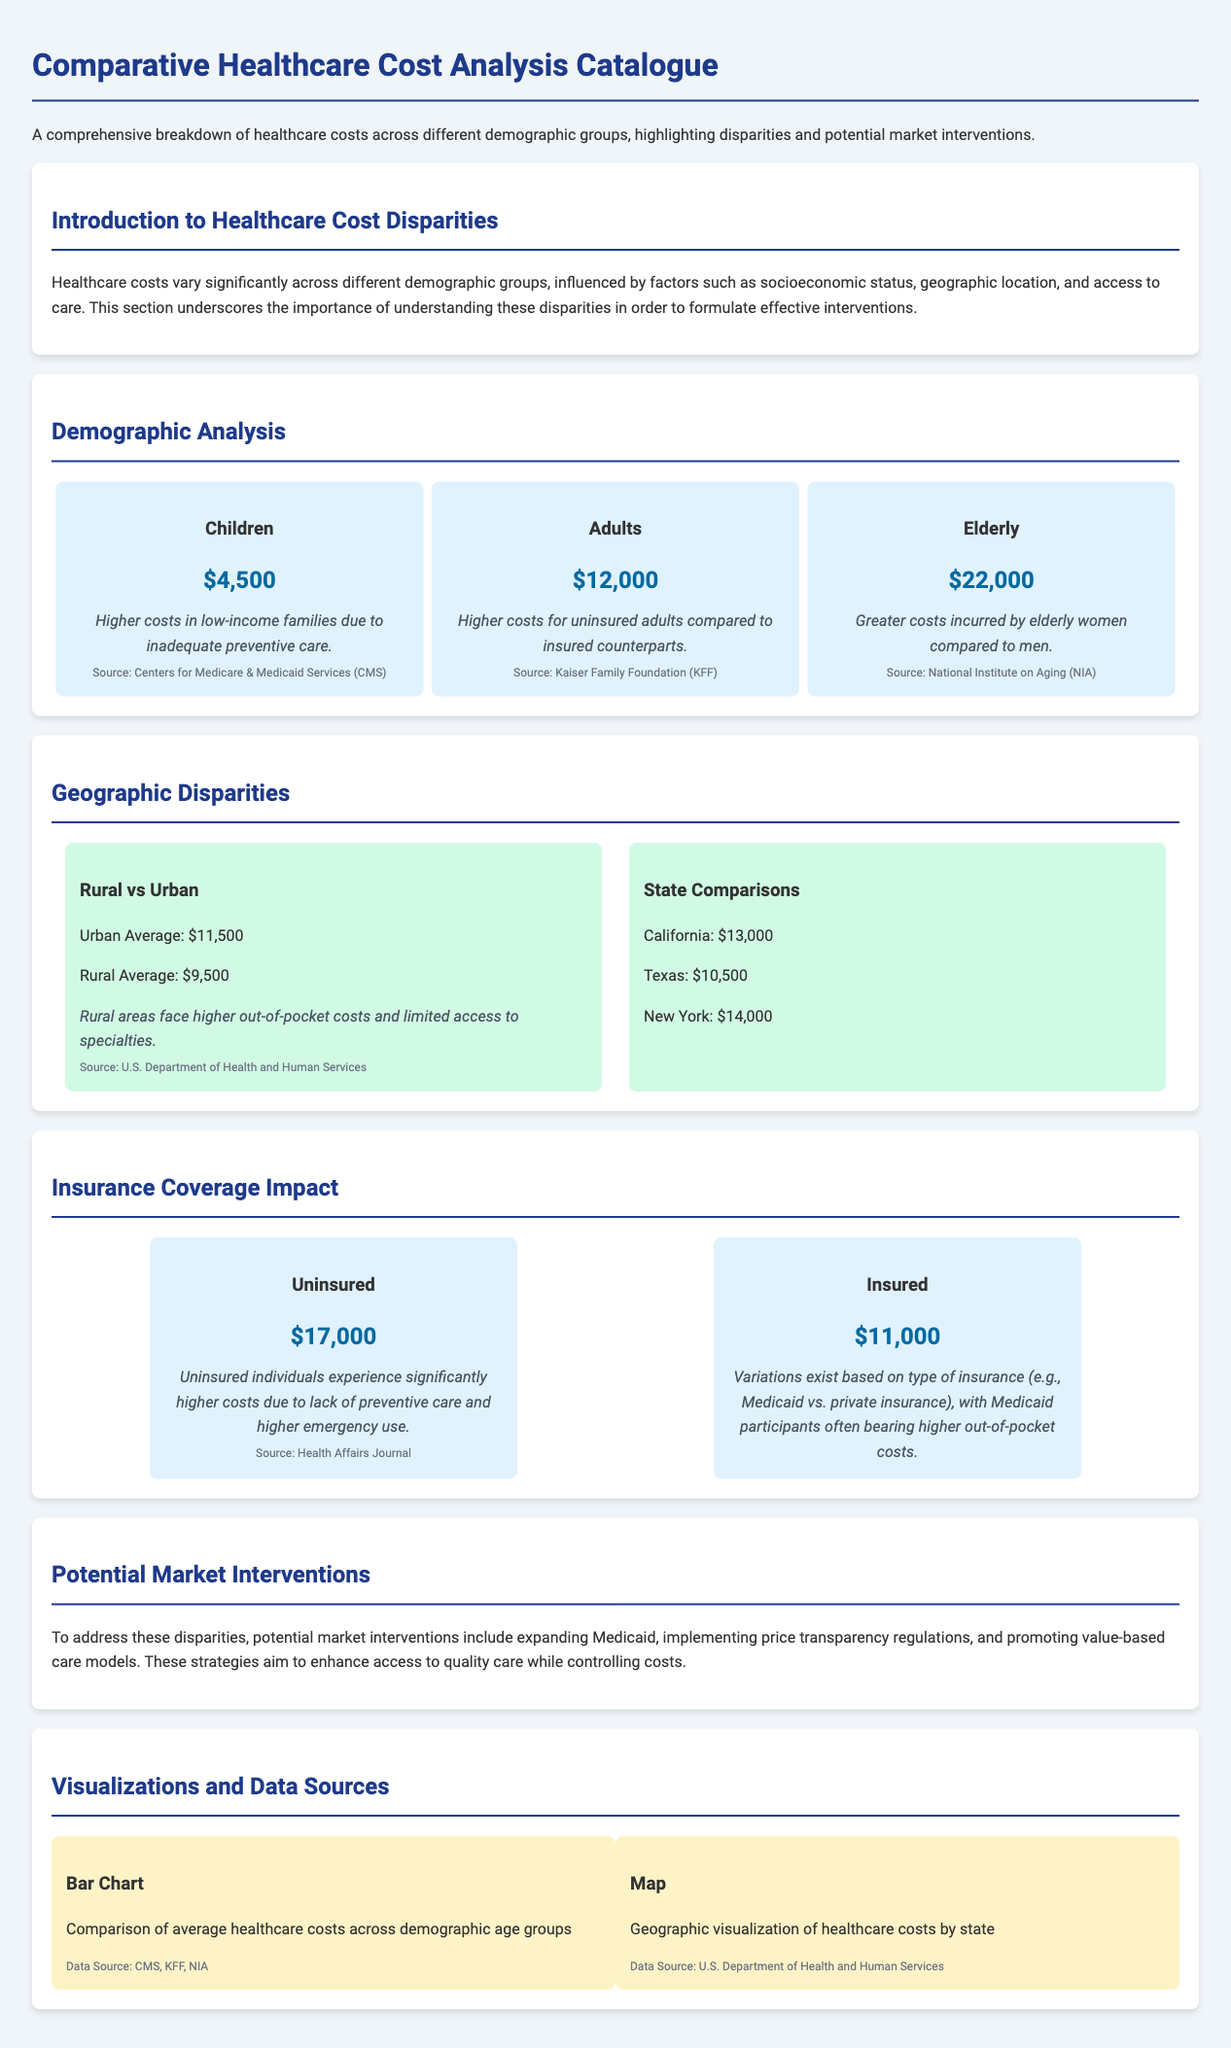what is the average healthcare cost for children? The average healthcare cost for children is provided in the document as $4,500.
Answer: $4,500 what is the cost difference between insured and uninsured individuals? The document states that uninsured individuals have a higher cost of $17,000 compared to insured individuals at $11,000, which means a difference of $6,000.
Answer: $6,000 which demographic group incurs greater costs, elderly women or elderly men? The document specifies that elderly women incur greater costs compared to men.
Answer: women what is the average healthcare cost in rural areas? The document states that the average healthcare cost in rural areas is $9,500.
Answer: $9,500 what kind of market intervention is suggested to address healthcare disparities? The document mentions expanding Medicaid as one of the potential market interventions.
Answer: expanding Medicaid how much are healthcare costs for the elderly? The document indicates that the healthcare costs for the elderly are $22,000.
Answer: $22,000 what geographical comparison shows the highest average healthcare costs? The document lists New York as having the highest average healthcare cost among the states compared, at $14,000.
Answer: New York what type of visualization compares average healthcare costs across demographic age groups? The document describes a bar chart for comparing average healthcare costs across demographic age groups.
Answer: bar chart what do rural areas face regarding healthcare costs? The document mentions that rural areas face higher out-of-pocket costs and limited access to specialties.
Answer: higher out-of-pocket costs 